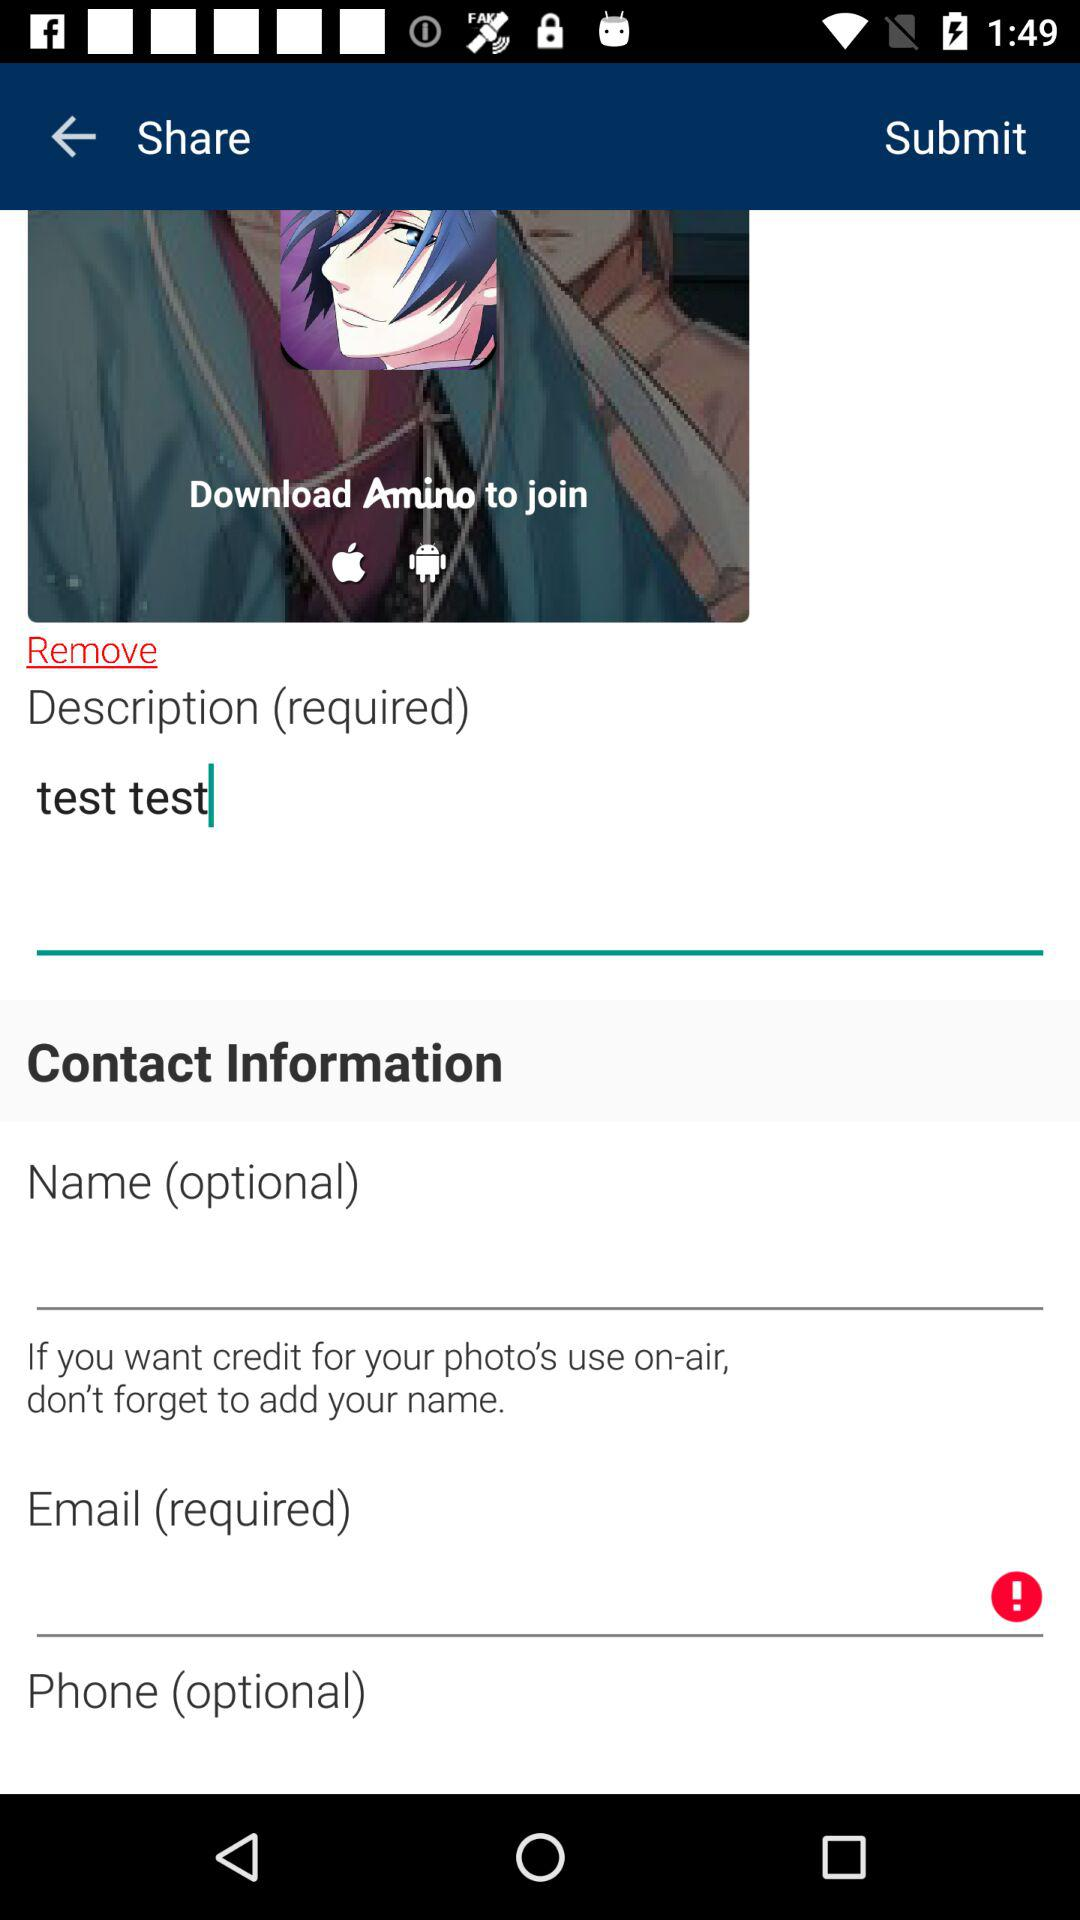What is the name of the application? The name of the application is "Amino". 